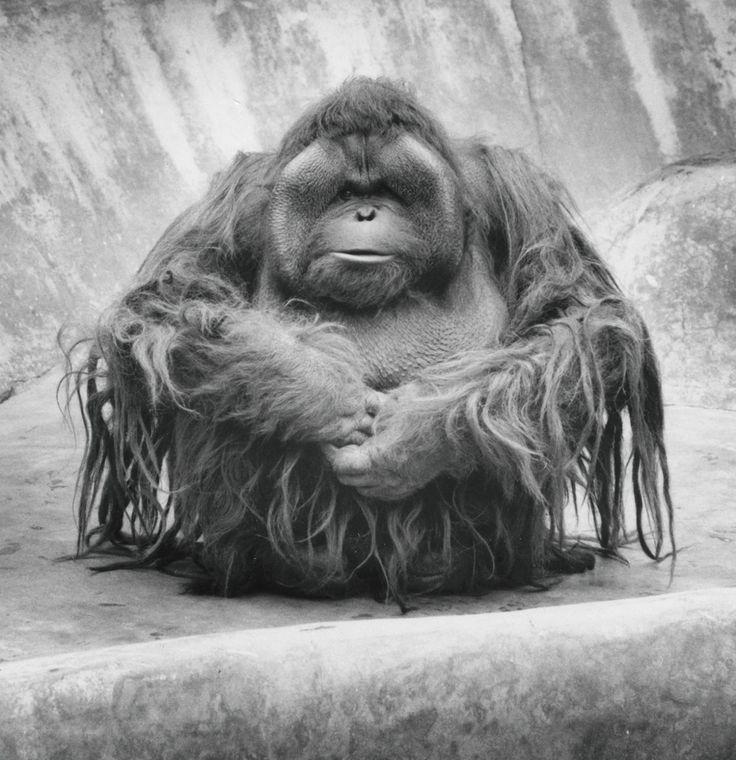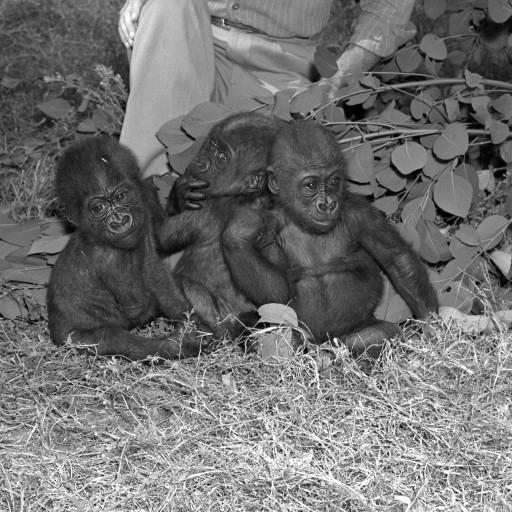The first image is the image on the left, the second image is the image on the right. For the images displayed, is the sentence "A female ape is holding a baby ape." factually correct? Answer yes or no. No. The first image is the image on the left, the second image is the image on the right. Assess this claim about the two images: "One image contains a group of three apes, and the other image features one adult gorilla sitting with a baby gorilla that is on the adult's chest and facing forward.". Correct or not? Answer yes or no. No. 